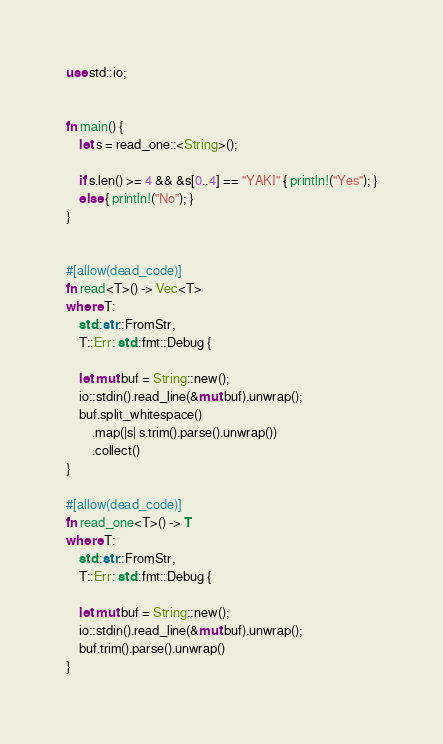Convert code to text. <code><loc_0><loc_0><loc_500><loc_500><_Rust_>use std::io;


fn main() {
    let s = read_one::<String>();

    if s.len() >= 4 && &s[0..4] == "YAKI" { println!("Yes"); }
    else { println!("No"); }
}


#[allow(dead_code)]
fn read<T>() -> Vec<T>
where T:
    std::str::FromStr,
    T::Err: std::fmt::Debug {

    let mut buf = String::new();
    io::stdin().read_line(&mut buf).unwrap();
    buf.split_whitespace()
        .map(|s| s.trim().parse().unwrap())
        .collect()
}

#[allow(dead_code)]
fn read_one<T>() -> T
where T:
    std::str::FromStr,
    T::Err: std::fmt::Debug {

    let mut buf = String::new();
    io::stdin().read_line(&mut buf).unwrap();
    buf.trim().parse().unwrap()
}</code> 